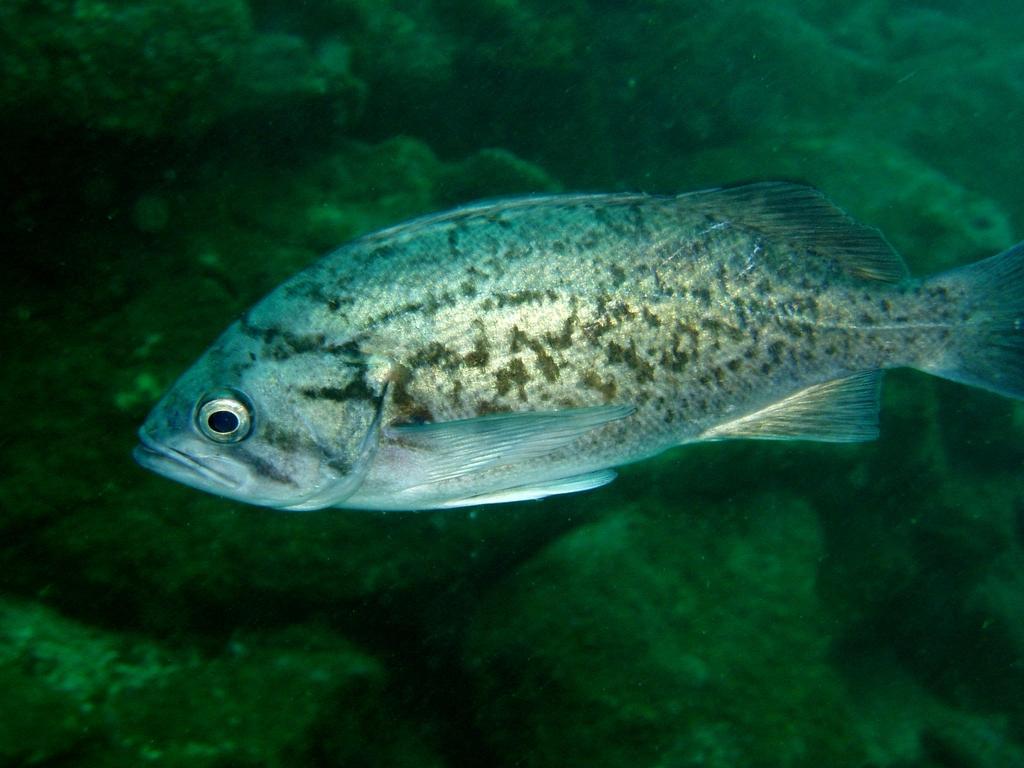Can you describe this image briefly? There is a fish in the water. In the background, there are rocks. 